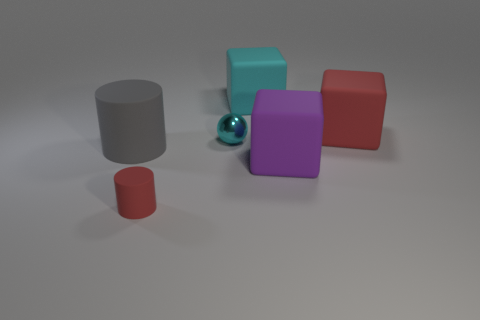Are there any reflections or shadows in the scene? Yes, subtle shadows are visible beneath the objects, indicating a light source above them. 